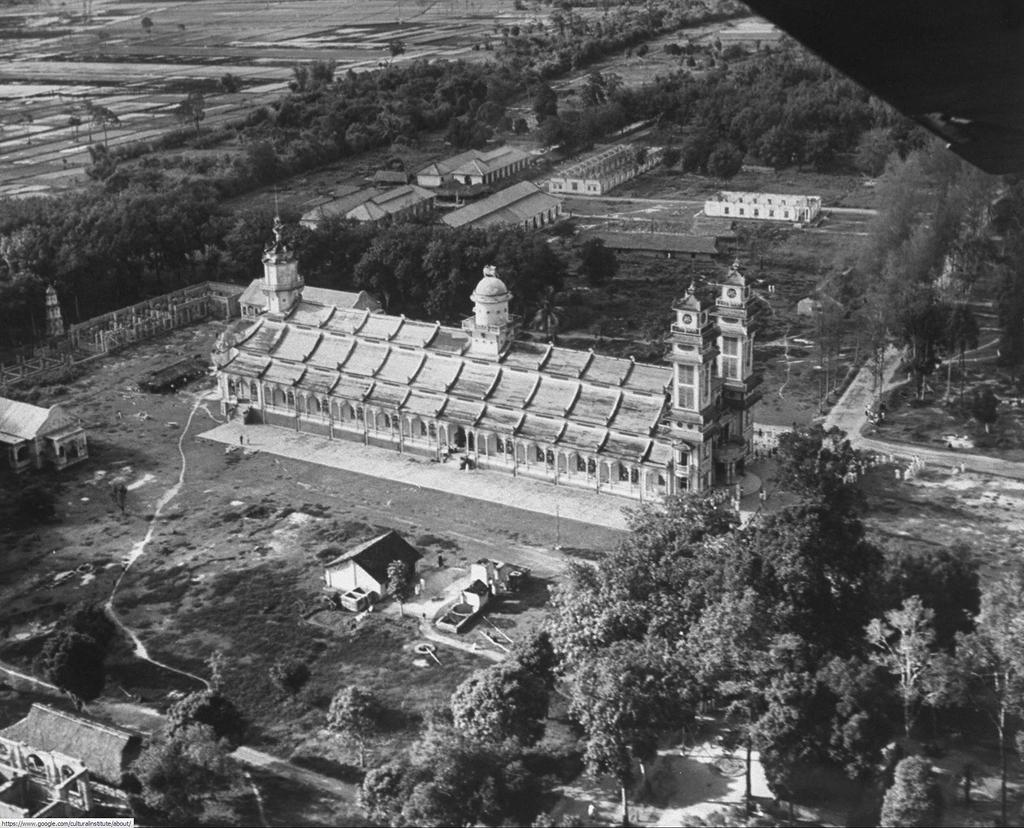What type of natural elements can be seen in the image? There are trees in the image. What type of man-made structures are present in the image? There are buildings in the image. What is the color scheme of the image? The image is black and white in color. How many shirts are hanging on the trees in the image? There are no shirts present in the image; it features trees and buildings. What type of humor can be observed in the image? There is no humor present in the image, as it is a simple depiction of trees and buildings. 